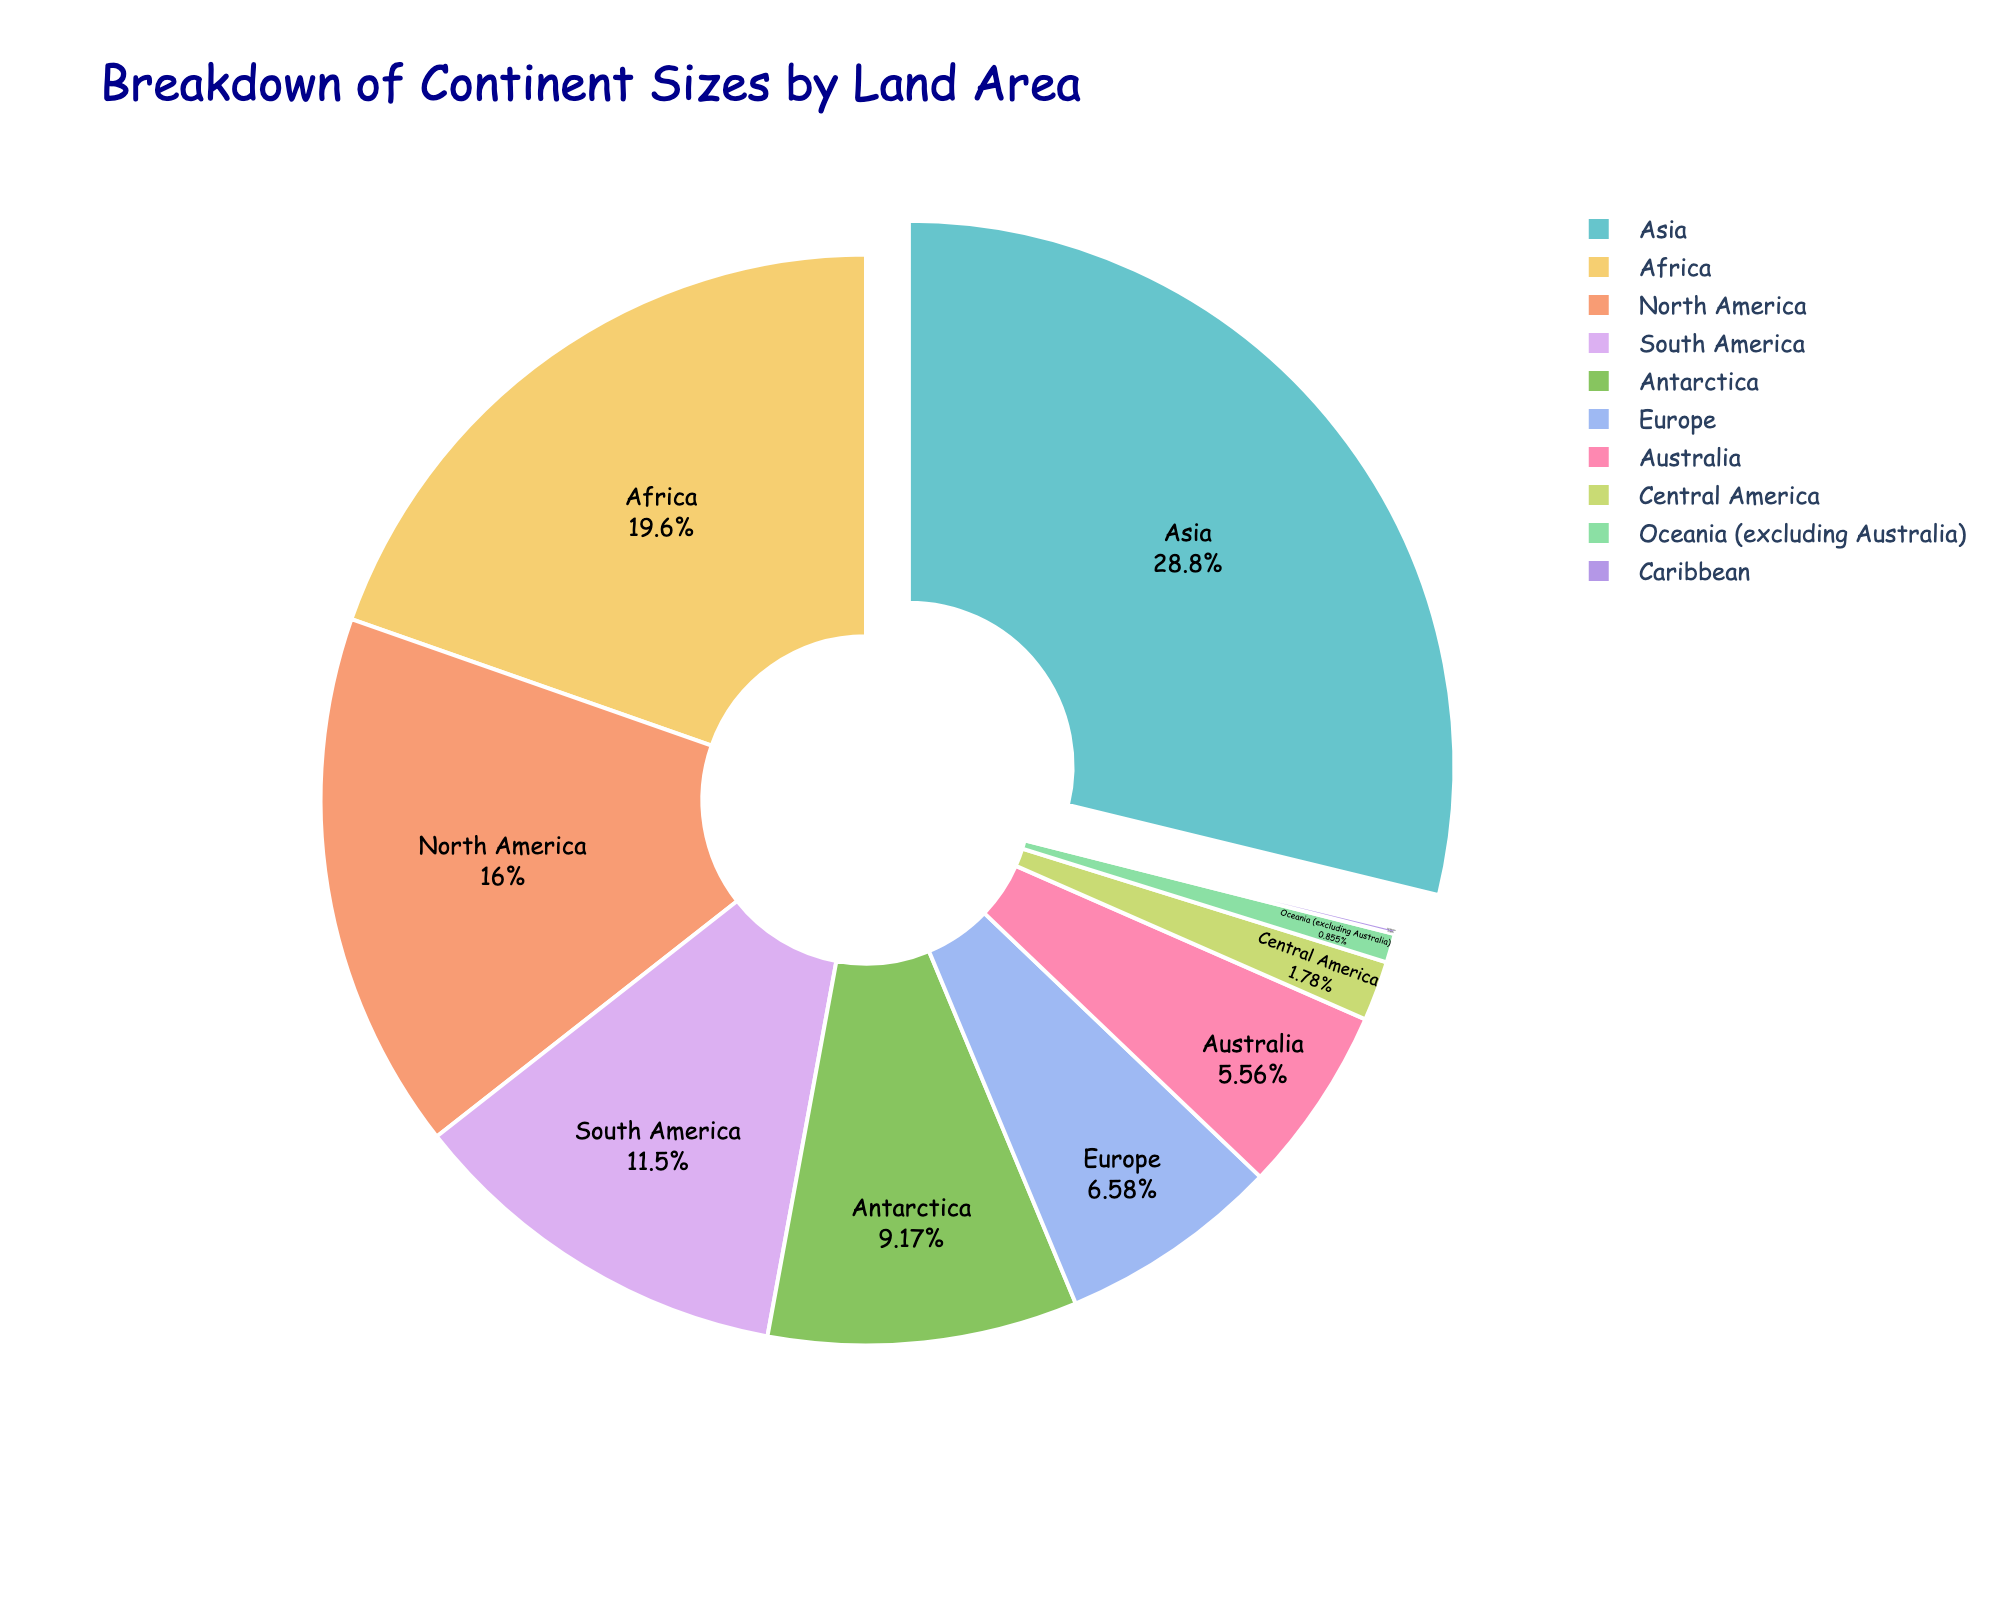What percentage of land area does Asia cover? Look at the slice labeled "Asia" on the pie chart. The figure should show the percentage of the total land area for each continent.
Answer: (Insert percentage value from the pie chart for Asia) Which continent has the smallest land area? Compare the sizes of all slices in the pie chart. Identify the smallest slice to determine the continent with the smallest land area.
Answer: Caribbean How much larger is Asia's land area compared to Europe? Find Asia and Europe's percentages or absolute values in the pie chart. Subtract Europe's land area from Asia's land area. If percentages are displayed, you can use those instead.
Answer: (Insert corresponding value based on the difference between Asia and Europe) What is the combined land area percentage of North America and South America? Look at the pie chart slices labeled "North America" and "South America". Add their percentages together to get the combined total.
Answer: (Insert the sum of North America and South America's percentages) Which continent has a larger land area: Africa or Antarctica? Compare the slices labeled "Africa" and "Antarctica" in the pie chart. The larger slice will indicate the continent with the larger land area.
Answer: Africa What is the visual difference between the slice representing Oceania (excluding Australia) and Central America? Look at the pie chart and compare the sizes and colors of the slices for "Oceania (excluding Australia)" and "Central America". Describe any noticeable difference.
Answer: (Insert description based on the visual representation) By what percentage does Europe’s land area exceed that of Australia? Find the percentage values or absolute land area for Europe and Australia in the pie chart. Subtract Australia's percentage from Europe's percentage (or similar with the absolute values) and provide the result.
Answer: (Insert percentage difference) What is the total land area in percentage for all continents excluding Asia and Africa? Identify and add up the percentage values or proportions for all slices other than "Asia" and "Africa". This gives the remaining percentage of the total land area.
Answer: (Insert total percentage excluding Asia and Africa) How does the land area of South America compare visually to that of North America? Examine the slices labeled "South America" and "North America" on the pie chart. Describe the relative size difference.
Answer: South America is smaller than North America If you combined the land areas of Europe and Central America, how would it compare to the land area of Africa? Add the percentages or absolute values of "Europe" and "Central America" from the chart. Compare this sum to the percentage or absolute value for "Africa" and determine if it is greater or less.
Answer: (Insert comparison result based on value addition) 